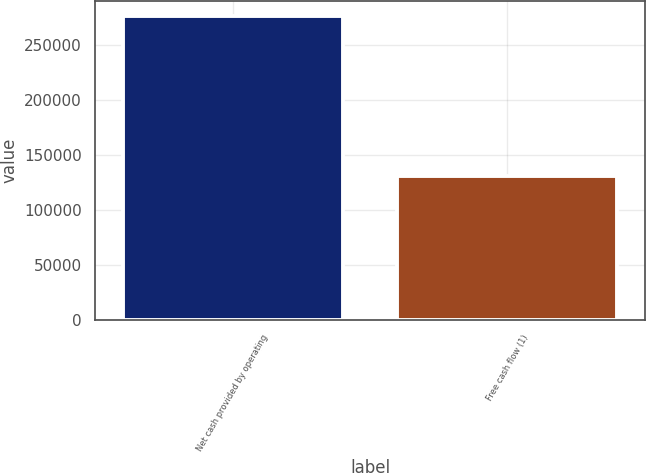Convert chart to OTSL. <chart><loc_0><loc_0><loc_500><loc_500><bar_chart><fcel>Net cash provided by operating<fcel>Free cash flow (1)<nl><fcel>276401<fcel>131007<nl></chart> 